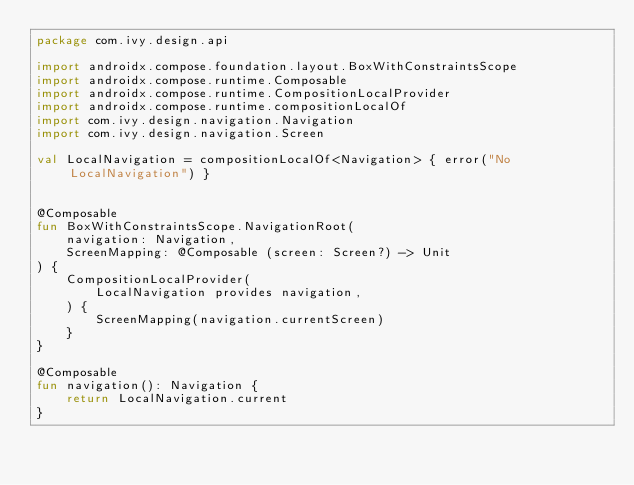Convert code to text. <code><loc_0><loc_0><loc_500><loc_500><_Kotlin_>package com.ivy.design.api

import androidx.compose.foundation.layout.BoxWithConstraintsScope
import androidx.compose.runtime.Composable
import androidx.compose.runtime.CompositionLocalProvider
import androidx.compose.runtime.compositionLocalOf
import com.ivy.design.navigation.Navigation
import com.ivy.design.navigation.Screen

val LocalNavigation = compositionLocalOf<Navigation> { error("No LocalNavigation") }


@Composable
fun BoxWithConstraintsScope.NavigationRoot(
    navigation: Navigation,
    ScreenMapping: @Composable (screen: Screen?) -> Unit
) {
    CompositionLocalProvider(
        LocalNavigation provides navigation,
    ) {
        ScreenMapping(navigation.currentScreen)
    }
}

@Composable
fun navigation(): Navigation {
    return LocalNavigation.current
}</code> 